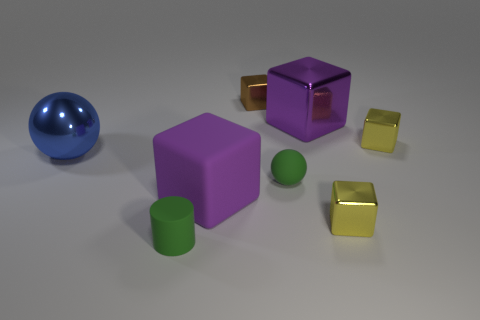Subtract 2 blocks. How many blocks are left? 3 Subtract all brown blocks. How many blocks are left? 4 Subtract all brown metallic blocks. How many blocks are left? 4 Subtract all brown blocks. Subtract all red spheres. How many blocks are left? 4 Add 2 small rubber spheres. How many objects exist? 10 Subtract all balls. How many objects are left? 6 Add 7 purple metal objects. How many purple metal objects are left? 8 Add 1 small metallic cylinders. How many small metallic cylinders exist? 1 Subtract 0 gray balls. How many objects are left? 8 Subtract all tiny gray rubber objects. Subtract all matte objects. How many objects are left? 5 